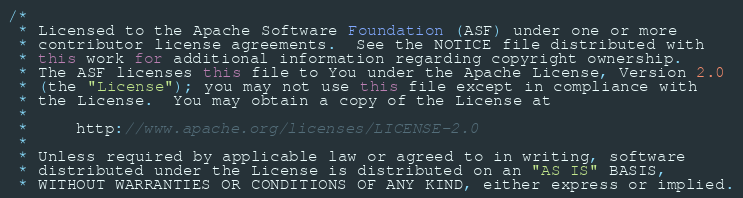Convert code to text. <code><loc_0><loc_0><loc_500><loc_500><_Java_>/*
 * Licensed to the Apache Software Foundation (ASF) under one or more
 * contributor license agreements.  See the NOTICE file distributed with
 * this work for additional information regarding copyright ownership.
 * The ASF licenses this file to You under the Apache License, Version 2.0
 * (the "License"); you may not use this file except in compliance with
 * the License.  You may obtain a copy of the License at
 *
 *     http://www.apache.org/licenses/LICENSE-2.0
 *
 * Unless required by applicable law or agreed to in writing, software
 * distributed under the License is distributed on an "AS IS" BASIS,
 * WITHOUT WARRANTIES OR CONDITIONS OF ANY KIND, either express or implied.</code> 